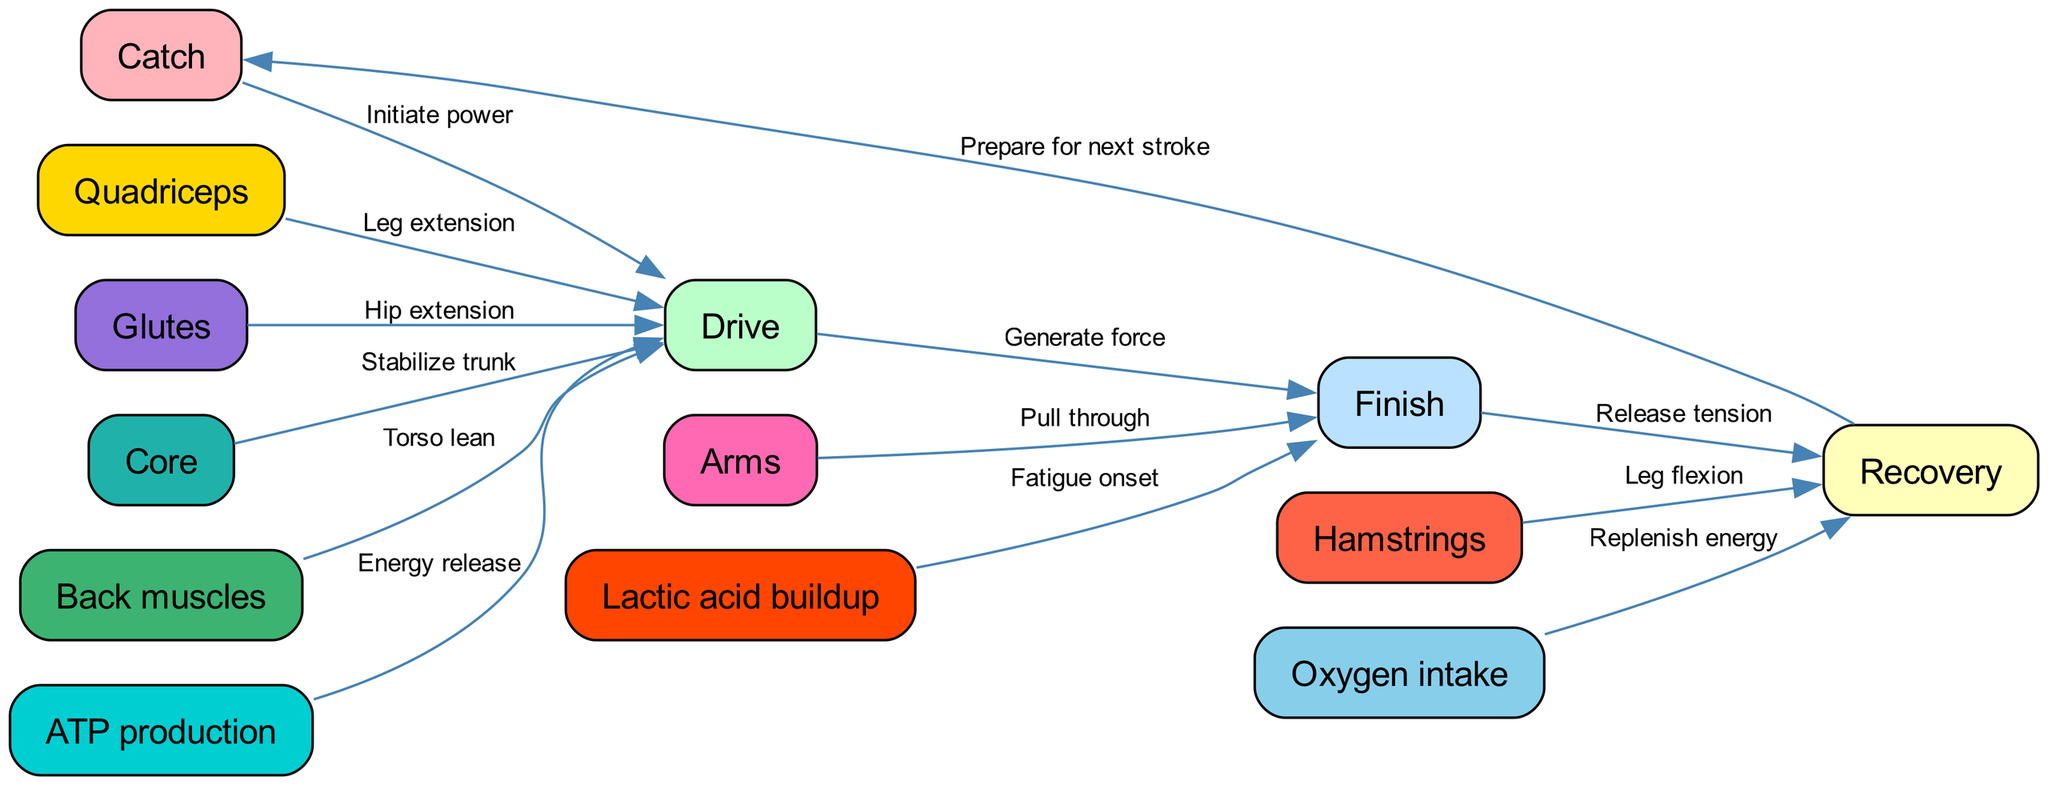What are the total number of nodes in the graph? The diagram specifies 13 nodes in total, which are distinct components related to the rowing stroke, including phases like Catch, Drive, Finish, and Recovery, as well as muscle groups and energy aspects.
Answer: 13 Which node represents the beginning of the rowing stroke? The 'Catch' node is identified as the starting point in the rowing stroke sequence, marking the initial engagement phase before power is applied.
Answer: Catch What is the relationship between 'Oxygen intake' and 'Recovery'? The directed edge indicates that 'Oxygen intake' is essential for 'Recovery', as it contributes to replenishing energy during this phase after the exertion of the stroke.
Answer: Replenish energy Which muscle group is associated with 'Leg flexion'? The 'Hamstrings' node is directly linked to the 'Recovery' phase by the labeled edge that emphasizes their role in leg flexion as the body prepares for the catch after a stroke.
Answer: Hamstrings What is the function of 'ATP production' in the graph? 'ATP production' is connected to the 'Drive' phase, showcasing its role in providing the energy necessary for rowing through an energy release during the stroke.
Answer: Energy release Which phase follows the 'Finish'? According to the directed flow, the operation 'Finish' leads directly to 'Recovery', indicating that this is the next phase after completing the stroke.
Answer: Recovery How does 'Lactic acid buildup' influence the rowing stroke? The edge from 'Lactic acid buildup' to 'Finish' denotes that as lactic acid accumulates, it indicates the onset of fatigue, potentially impacting performance during this phase.
Answer: Fatigue onset What links 'Back muscles' and 'Drive'? The directed edge from 'Back muscles' to 'Drive' signifies that the engagement of the back muscles contributes to the 'Drive' phase via torso lean, enhancing the rowing force generated.
Answer: Torso lean Which muscle group is responsible for 'Hip extension'? The 'Glutes' node is connected to the 'Drive' phase illustrating their role in driving the rowing power through hip extension during that part of the stroke.
Answer: Glutes 